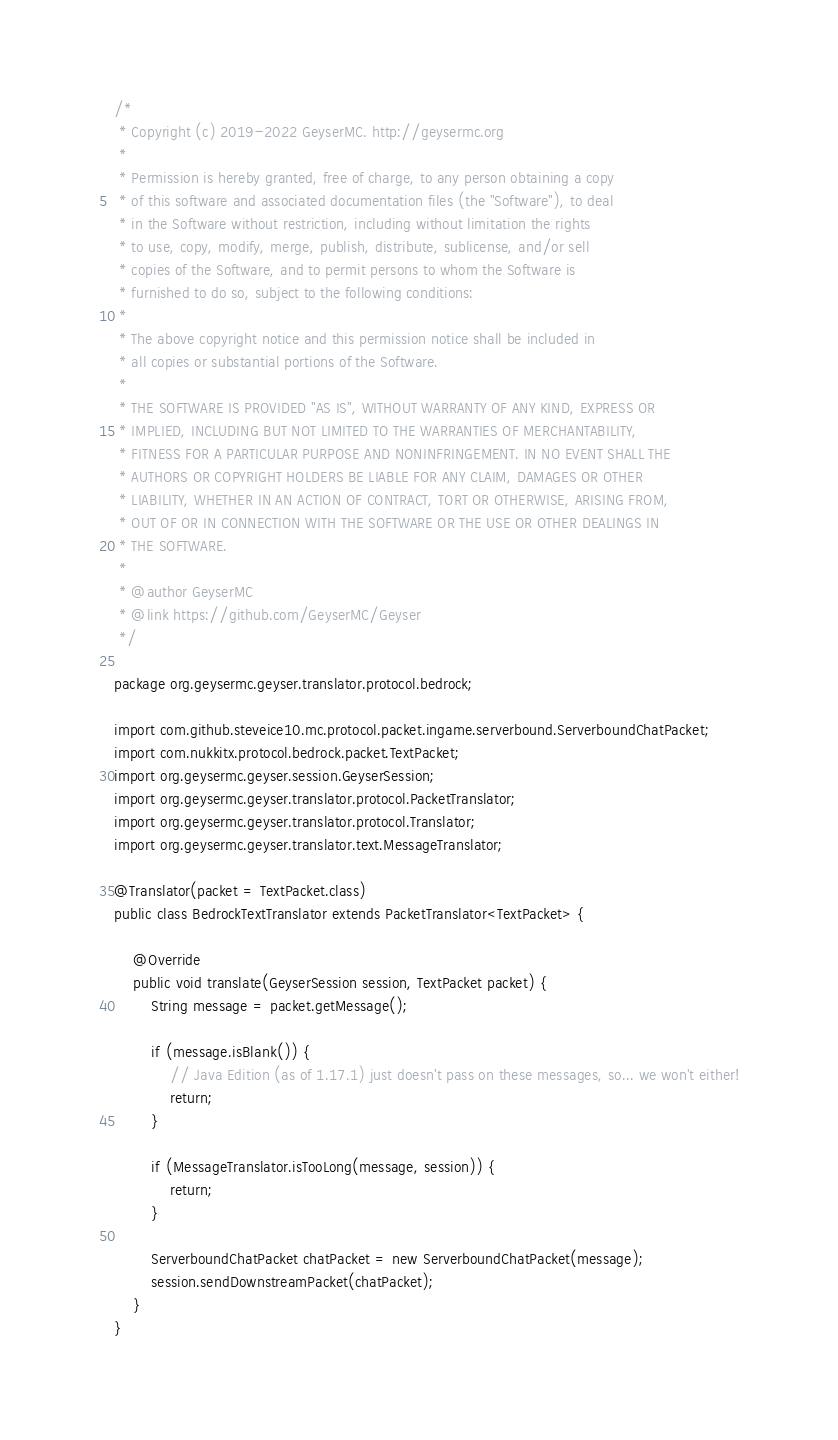Convert code to text. <code><loc_0><loc_0><loc_500><loc_500><_Java_>/*
 * Copyright (c) 2019-2022 GeyserMC. http://geysermc.org
 *
 * Permission is hereby granted, free of charge, to any person obtaining a copy
 * of this software and associated documentation files (the "Software"), to deal
 * in the Software without restriction, including without limitation the rights
 * to use, copy, modify, merge, publish, distribute, sublicense, and/or sell
 * copies of the Software, and to permit persons to whom the Software is
 * furnished to do so, subject to the following conditions:
 *
 * The above copyright notice and this permission notice shall be included in
 * all copies or substantial portions of the Software.
 *
 * THE SOFTWARE IS PROVIDED "AS IS", WITHOUT WARRANTY OF ANY KIND, EXPRESS OR
 * IMPLIED, INCLUDING BUT NOT LIMITED TO THE WARRANTIES OF MERCHANTABILITY,
 * FITNESS FOR A PARTICULAR PURPOSE AND NONINFRINGEMENT. IN NO EVENT SHALL THE
 * AUTHORS OR COPYRIGHT HOLDERS BE LIABLE FOR ANY CLAIM, DAMAGES OR OTHER
 * LIABILITY, WHETHER IN AN ACTION OF CONTRACT, TORT OR OTHERWISE, ARISING FROM,
 * OUT OF OR IN CONNECTION WITH THE SOFTWARE OR THE USE OR OTHER DEALINGS IN
 * THE SOFTWARE.
 *
 * @author GeyserMC
 * @link https://github.com/GeyserMC/Geyser
 */

package org.geysermc.geyser.translator.protocol.bedrock;

import com.github.steveice10.mc.protocol.packet.ingame.serverbound.ServerboundChatPacket;
import com.nukkitx.protocol.bedrock.packet.TextPacket;
import org.geysermc.geyser.session.GeyserSession;
import org.geysermc.geyser.translator.protocol.PacketTranslator;
import org.geysermc.geyser.translator.protocol.Translator;
import org.geysermc.geyser.translator.text.MessageTranslator;

@Translator(packet = TextPacket.class)
public class BedrockTextTranslator extends PacketTranslator<TextPacket> {

    @Override
    public void translate(GeyserSession session, TextPacket packet) {
        String message = packet.getMessage();

        if (message.isBlank()) {
            // Java Edition (as of 1.17.1) just doesn't pass on these messages, so... we won't either!
            return;
        }

        if (MessageTranslator.isTooLong(message, session)) {
            return;
        }

        ServerboundChatPacket chatPacket = new ServerboundChatPacket(message);
        session.sendDownstreamPacket(chatPacket);
    }
}
</code> 